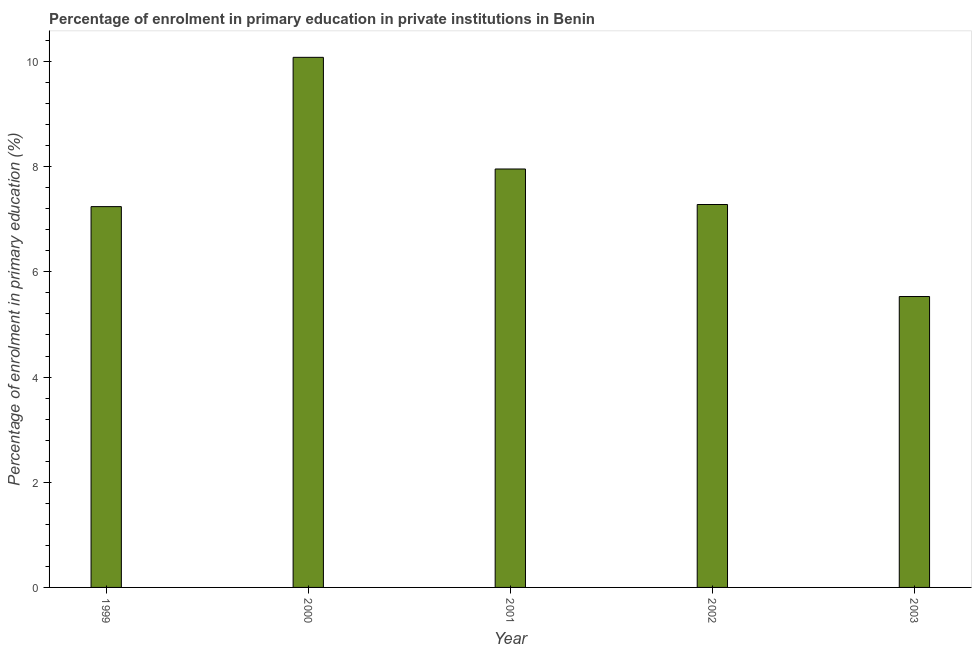Does the graph contain any zero values?
Your answer should be very brief. No. What is the title of the graph?
Ensure brevity in your answer.  Percentage of enrolment in primary education in private institutions in Benin. What is the label or title of the X-axis?
Offer a very short reply. Year. What is the label or title of the Y-axis?
Provide a succinct answer. Percentage of enrolment in primary education (%). What is the enrolment percentage in primary education in 2000?
Keep it short and to the point. 10.08. Across all years, what is the maximum enrolment percentage in primary education?
Your answer should be very brief. 10.08. Across all years, what is the minimum enrolment percentage in primary education?
Your answer should be compact. 5.53. In which year was the enrolment percentage in primary education maximum?
Offer a very short reply. 2000. What is the sum of the enrolment percentage in primary education?
Provide a succinct answer. 38.09. What is the difference between the enrolment percentage in primary education in 2000 and 2003?
Your answer should be very brief. 4.55. What is the average enrolment percentage in primary education per year?
Offer a terse response. 7.62. What is the median enrolment percentage in primary education?
Give a very brief answer. 7.28. In how many years, is the enrolment percentage in primary education greater than 8.8 %?
Give a very brief answer. 1. Do a majority of the years between 1999 and 2000 (inclusive) have enrolment percentage in primary education greater than 2 %?
Your answer should be compact. Yes. What is the ratio of the enrolment percentage in primary education in 1999 to that in 2001?
Offer a very short reply. 0.91. Is the difference between the enrolment percentage in primary education in 1999 and 2001 greater than the difference between any two years?
Your answer should be very brief. No. What is the difference between the highest and the second highest enrolment percentage in primary education?
Your response must be concise. 2.12. Is the sum of the enrolment percentage in primary education in 1999 and 2001 greater than the maximum enrolment percentage in primary education across all years?
Offer a very short reply. Yes. What is the difference between the highest and the lowest enrolment percentage in primary education?
Provide a succinct answer. 4.55. In how many years, is the enrolment percentage in primary education greater than the average enrolment percentage in primary education taken over all years?
Your answer should be very brief. 2. How many bars are there?
Your answer should be compact. 5. Are all the bars in the graph horizontal?
Ensure brevity in your answer.  No. What is the Percentage of enrolment in primary education (%) of 1999?
Offer a very short reply. 7.24. What is the Percentage of enrolment in primary education (%) in 2000?
Provide a short and direct response. 10.08. What is the Percentage of enrolment in primary education (%) of 2001?
Offer a very short reply. 7.96. What is the Percentage of enrolment in primary education (%) of 2002?
Offer a terse response. 7.28. What is the Percentage of enrolment in primary education (%) of 2003?
Your answer should be compact. 5.53. What is the difference between the Percentage of enrolment in primary education (%) in 1999 and 2000?
Give a very brief answer. -2.84. What is the difference between the Percentage of enrolment in primary education (%) in 1999 and 2001?
Your response must be concise. -0.72. What is the difference between the Percentage of enrolment in primary education (%) in 1999 and 2002?
Provide a short and direct response. -0.04. What is the difference between the Percentage of enrolment in primary education (%) in 1999 and 2003?
Your response must be concise. 1.71. What is the difference between the Percentage of enrolment in primary education (%) in 2000 and 2001?
Offer a terse response. 2.12. What is the difference between the Percentage of enrolment in primary education (%) in 2000 and 2002?
Provide a short and direct response. 2.8. What is the difference between the Percentage of enrolment in primary education (%) in 2000 and 2003?
Provide a short and direct response. 4.55. What is the difference between the Percentage of enrolment in primary education (%) in 2001 and 2002?
Keep it short and to the point. 0.68. What is the difference between the Percentage of enrolment in primary education (%) in 2001 and 2003?
Make the answer very short. 2.43. What is the difference between the Percentage of enrolment in primary education (%) in 2002 and 2003?
Offer a very short reply. 1.75. What is the ratio of the Percentage of enrolment in primary education (%) in 1999 to that in 2000?
Your response must be concise. 0.72. What is the ratio of the Percentage of enrolment in primary education (%) in 1999 to that in 2001?
Offer a terse response. 0.91. What is the ratio of the Percentage of enrolment in primary education (%) in 1999 to that in 2003?
Your answer should be compact. 1.31. What is the ratio of the Percentage of enrolment in primary education (%) in 2000 to that in 2001?
Your answer should be compact. 1.27. What is the ratio of the Percentage of enrolment in primary education (%) in 2000 to that in 2002?
Offer a terse response. 1.38. What is the ratio of the Percentage of enrolment in primary education (%) in 2000 to that in 2003?
Your response must be concise. 1.82. What is the ratio of the Percentage of enrolment in primary education (%) in 2001 to that in 2002?
Offer a terse response. 1.09. What is the ratio of the Percentage of enrolment in primary education (%) in 2001 to that in 2003?
Make the answer very short. 1.44. What is the ratio of the Percentage of enrolment in primary education (%) in 2002 to that in 2003?
Your answer should be compact. 1.32. 